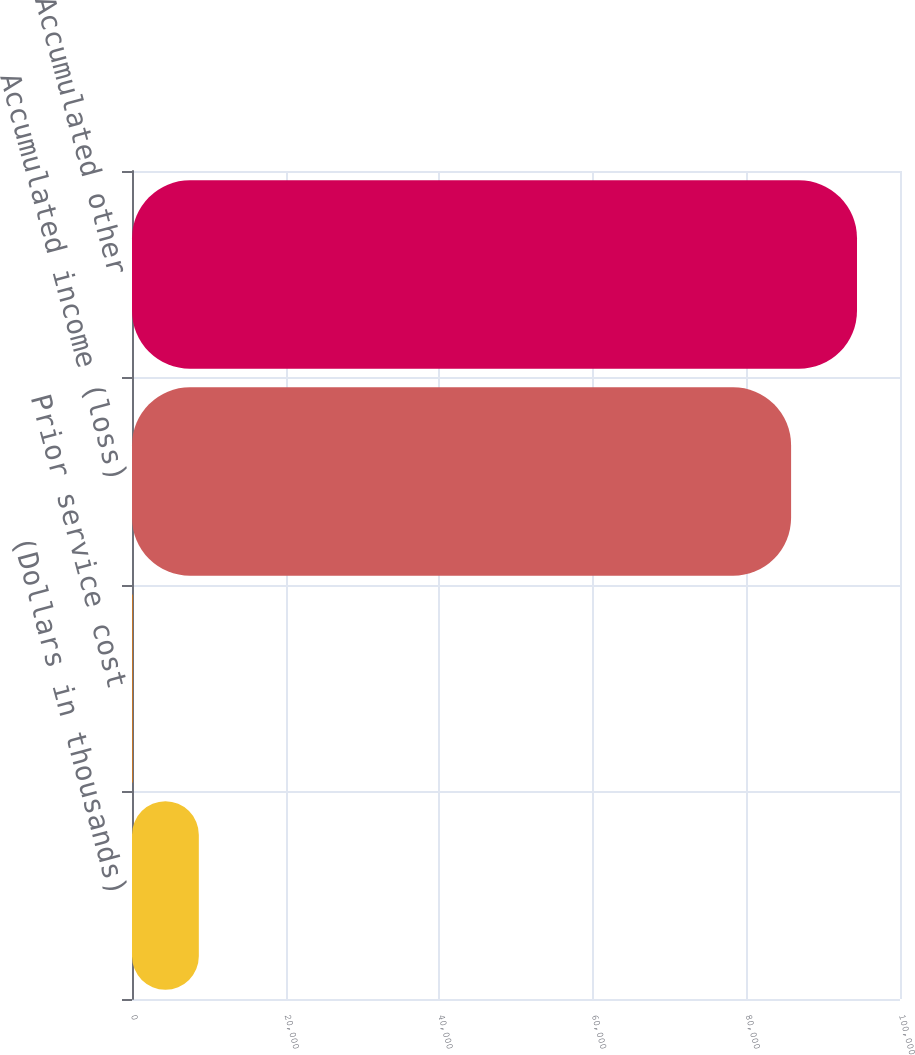Convert chart to OTSL. <chart><loc_0><loc_0><loc_500><loc_500><bar_chart><fcel>(Dollars in thousands)<fcel>Prior service cost<fcel>Accumulated income (loss)<fcel>Accumulated other<nl><fcel>8701<fcel>119<fcel>85820<fcel>94402<nl></chart> 